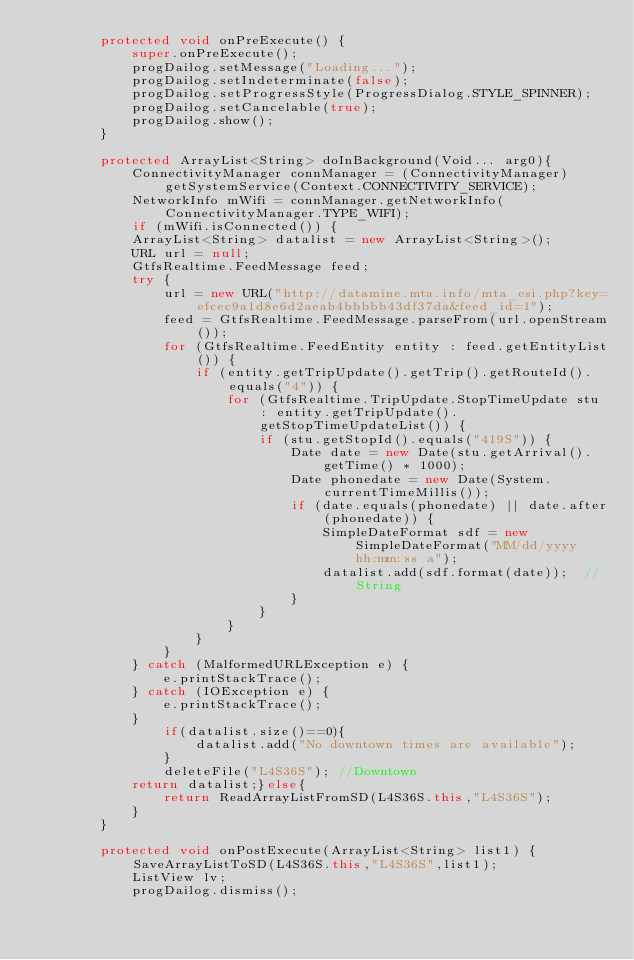Convert code to text. <code><loc_0><loc_0><loc_500><loc_500><_Java_>        protected void onPreExecute() {
            super.onPreExecute();
            progDailog.setMessage("Loading...");
            progDailog.setIndeterminate(false);
            progDailog.setProgressStyle(ProgressDialog.STYLE_SPINNER);
            progDailog.setCancelable(true);
            progDailog.show();
        }

        protected ArrayList<String> doInBackground(Void... arg0){
            ConnectivityManager connManager = (ConnectivityManager) getSystemService(Context.CONNECTIVITY_SERVICE);
            NetworkInfo mWifi = connManager.getNetworkInfo(ConnectivityManager.TYPE_WIFI);
            if (mWifi.isConnected()) {
            ArrayList<String> datalist = new ArrayList<String>();
            URL url = null;
            GtfsRealtime.FeedMessage feed;
            try {
                url = new URL("http://datamine.mta.info/mta_esi.php?key=efcec9a1d8e6d2aeab4bbbbb43df37da&feed_id=1");
                feed = GtfsRealtime.FeedMessage.parseFrom(url.openStream());
                for (GtfsRealtime.FeedEntity entity : feed.getEntityList()) {
                    if (entity.getTripUpdate().getTrip().getRouteId().equals("4")) {
                        for (GtfsRealtime.TripUpdate.StopTimeUpdate stu : entity.getTripUpdate().getStopTimeUpdateList()) {
                            if (stu.getStopId().equals("419S")) {
                                Date date = new Date(stu.getArrival().getTime() * 1000);
                                Date phonedate = new Date(System.currentTimeMillis());
                                if (date.equals(phonedate) || date.after(phonedate)) {
                                    SimpleDateFormat sdf = new SimpleDateFormat("MM/dd/yyyy  hh:mm:ss a");
                                    datalist.add(sdf.format(date));  //String
                                }
                            }
                        }
                    }
                }
            } catch (MalformedURLException e) {
                e.printStackTrace();
            } catch (IOException e) {
                e.printStackTrace();
            }
                if(datalist.size()==0){
                    datalist.add("No downtown times are available");
                }
                deleteFile("L4S36S");	//Downtown
            return datalist;}else{
                return ReadArrayListFromSD(L4S36S.this,"L4S36S");
            }
        }

        protected void onPostExecute(ArrayList<String> list1) {SaveArrayListToSD(L4S36S.this,"L4S36S",list1);
            ListView lv;
            progDailog.dismiss();</code> 